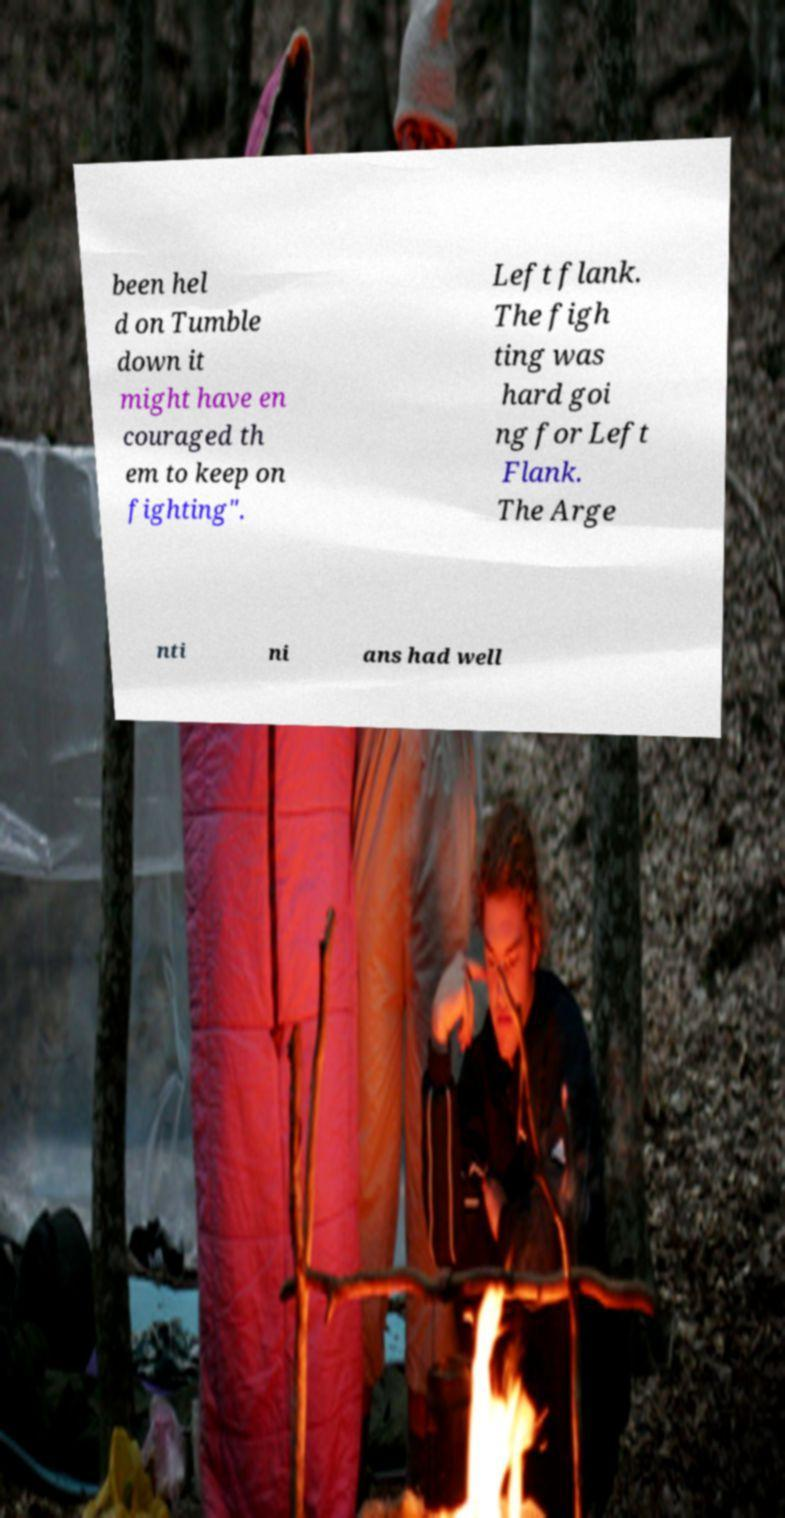Please identify and transcribe the text found in this image. been hel d on Tumble down it might have en couraged th em to keep on fighting". Left flank. The figh ting was hard goi ng for Left Flank. The Arge nti ni ans had well 